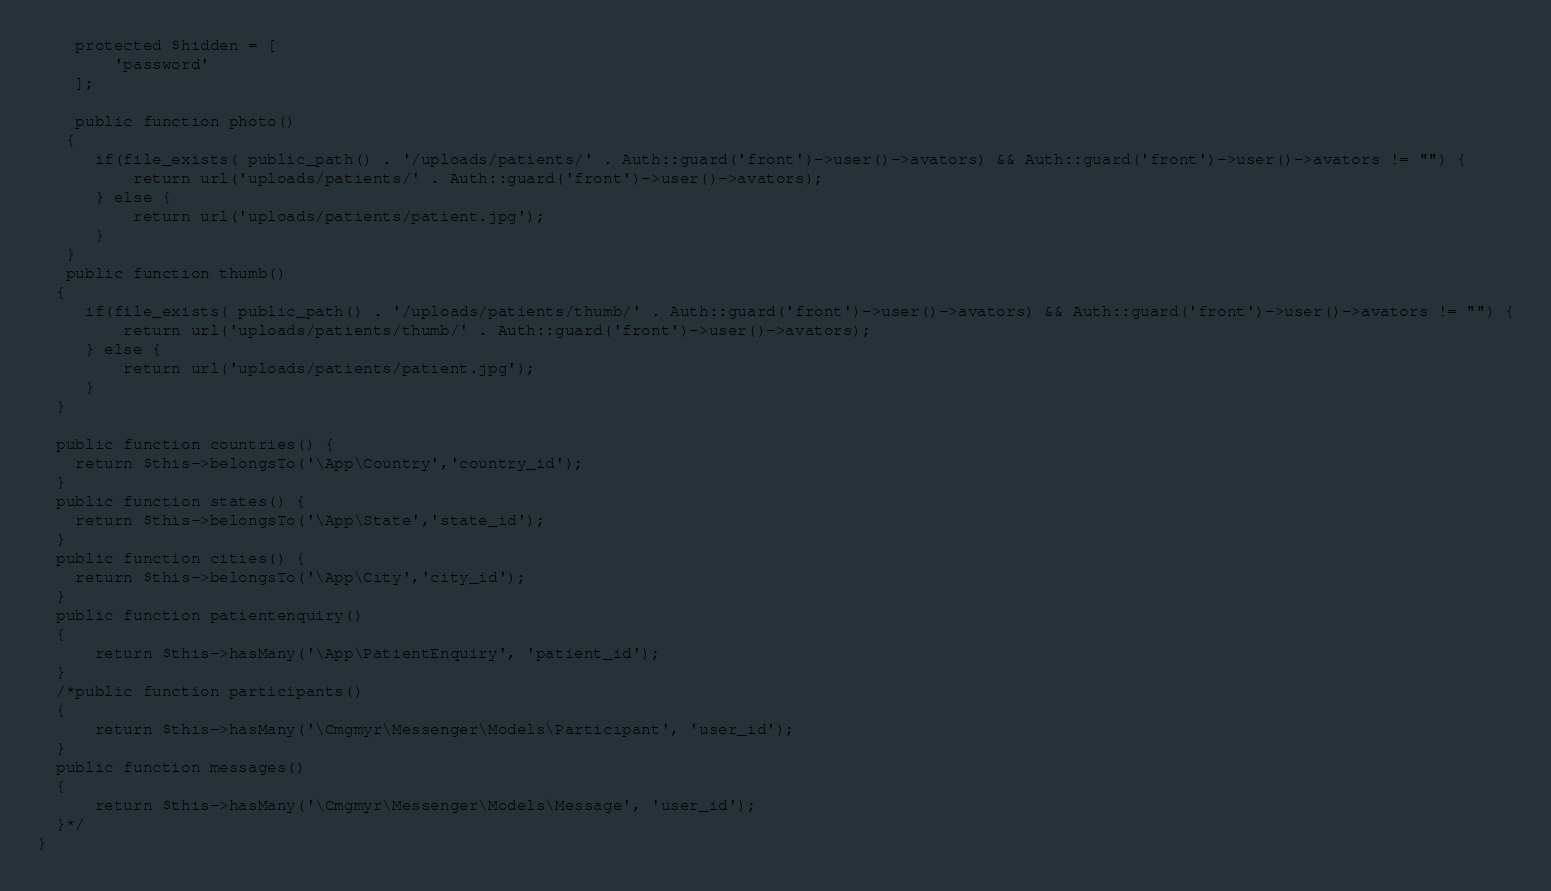Convert code to text. <code><loc_0><loc_0><loc_500><loc_500><_PHP_>    protected $hidden = [
        'password'
    ];

    public function photo()
   {
      if(file_exists( public_path() . '/uploads/patients/' . Auth::guard('front')->user()->avators) && Auth::guard('front')->user()->avators != "") {
          return url('uploads/patients/' . Auth::guard('front')->user()->avators);
      } else {
          return url('uploads/patients/patient.jpg');
      }
   }
   public function thumb()
  {
     if(file_exists( public_path() . '/uploads/patients/thumb/' . Auth::guard('front')->user()->avators) && Auth::guard('front')->user()->avators != "") {
         return url('uploads/patients/thumb/' . Auth::guard('front')->user()->avators);
     } else {
         return url('uploads/patients/patient.jpg');
     }
  }

  public function countries() {
    return $this->belongsTo('\App\Country','country_id');
  }
  public function states() {
    return $this->belongsTo('\App\State','state_id');
  }
  public function cities() {
    return $this->belongsTo('\App\City','city_id');
  }
  public function patientenquiry()
  {
      return $this->hasMany('\App\PatientEnquiry', 'patient_id');
  }
  /*public function participants()
  {
      return $this->hasMany('\Cmgmyr\Messenger\Models\Participant', 'user_id');
  }
  public function messages()
  {
      return $this->hasMany('\Cmgmyr\Messenger\Models\Message', 'user_id');
  }*/
}
</code> 